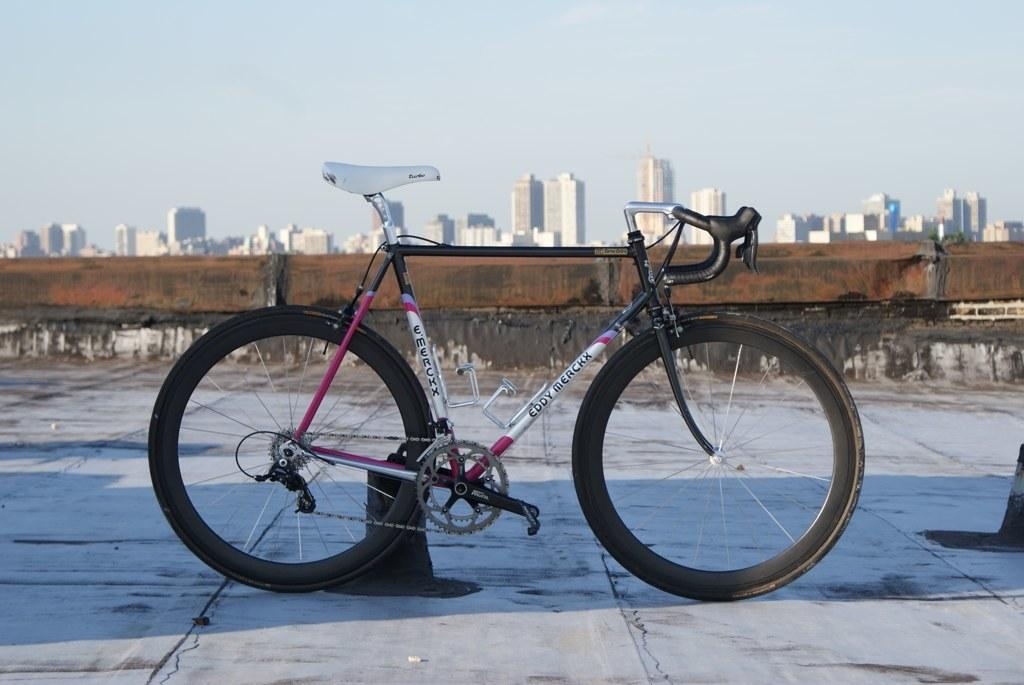What is the main subject in the middle of the image? There is a cycle in the middle of the image. What can be seen in the background of the image? There is a wall in the background of the image, and behind the wall, there are buildings. What is visible at the top of the image? The sky is visible at the top of the image. What arithmetic problem is being solved by the insect on the square in the image? There is no insect or square present in the image, and therefore no arithmetic problem can be observed. 